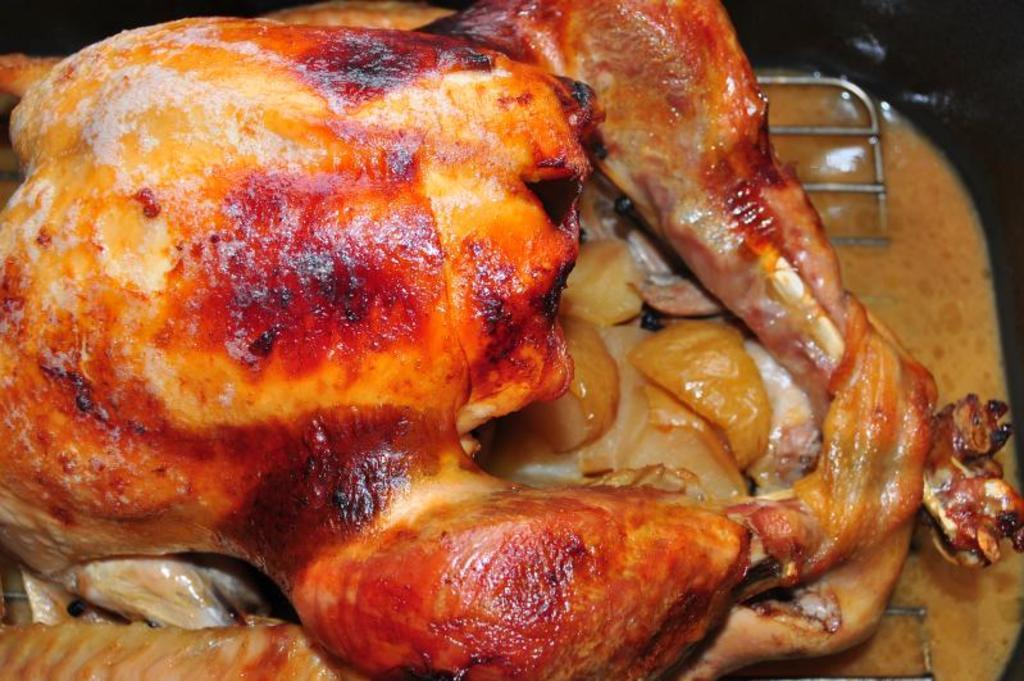What is the main subject of the image? There is a food item in the image. How is the food item presented in the image? The food item is in a platter. What is the purpose of the beggar in the image? There is no beggar present in the image. 